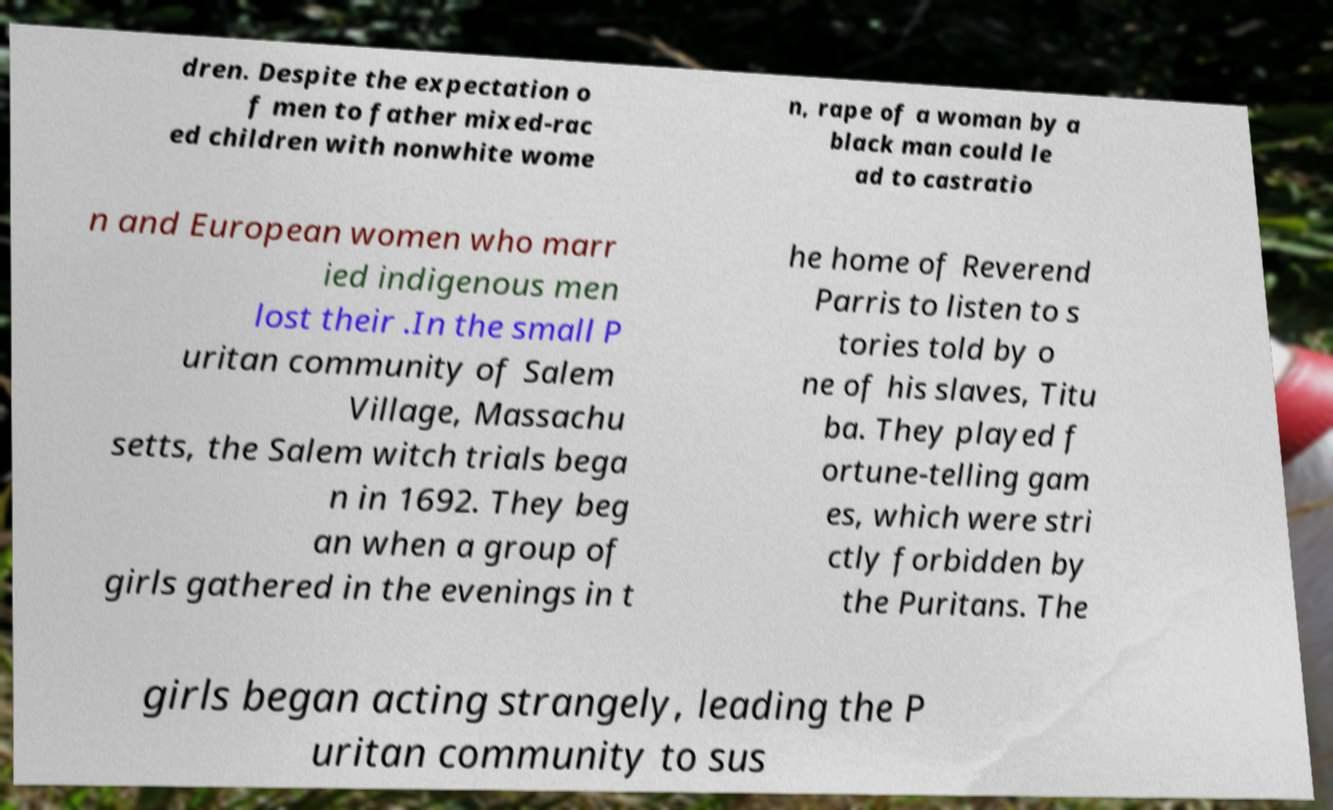Can you accurately transcribe the text from the provided image for me? dren. Despite the expectation o f men to father mixed-rac ed children with nonwhite wome n, rape of a woman by a black man could le ad to castratio n and European women who marr ied indigenous men lost their .In the small P uritan community of Salem Village, Massachu setts, the Salem witch trials bega n in 1692. They beg an when a group of girls gathered in the evenings in t he home of Reverend Parris to listen to s tories told by o ne of his slaves, Titu ba. They played f ortune-telling gam es, which were stri ctly forbidden by the Puritans. The girls began acting strangely, leading the P uritan community to sus 